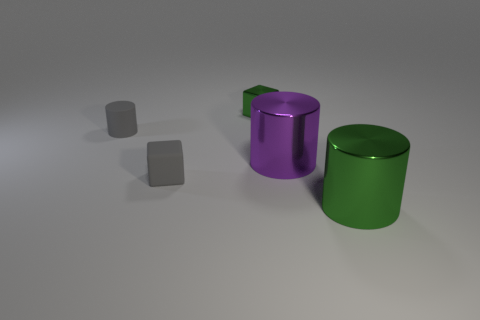Add 5 small gray rubber things. How many objects exist? 10 Subtract all cylinders. How many objects are left? 2 Subtract all rubber cylinders. Subtract all tiny shiny cubes. How many objects are left? 3 Add 2 green metallic cubes. How many green metallic cubes are left? 3 Add 1 tiny red things. How many tiny red things exist? 1 Subtract 0 yellow cubes. How many objects are left? 5 